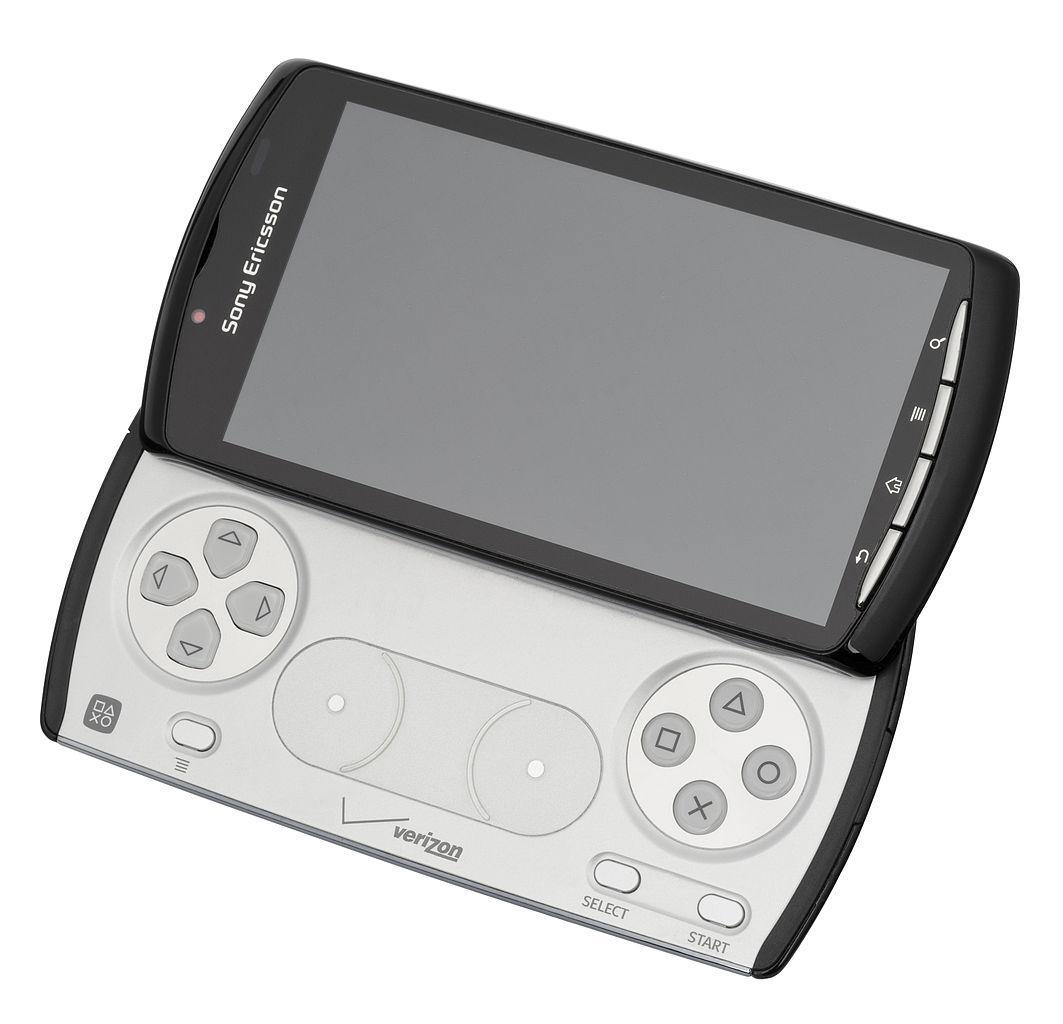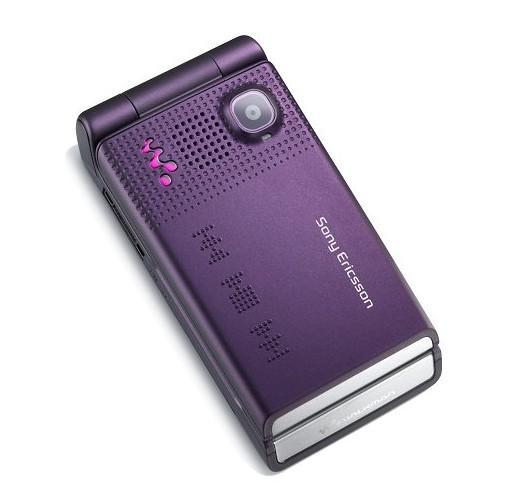The first image is the image on the left, the second image is the image on the right. Given the left and right images, does the statement "The image on the left shows an opened flip phone." hold true? Answer yes or no. No. The first image is the image on the left, the second image is the image on the right. For the images shown, is this caption "Three phones are laid out neatly side by side in one of the pictures." true? Answer yes or no. No. 